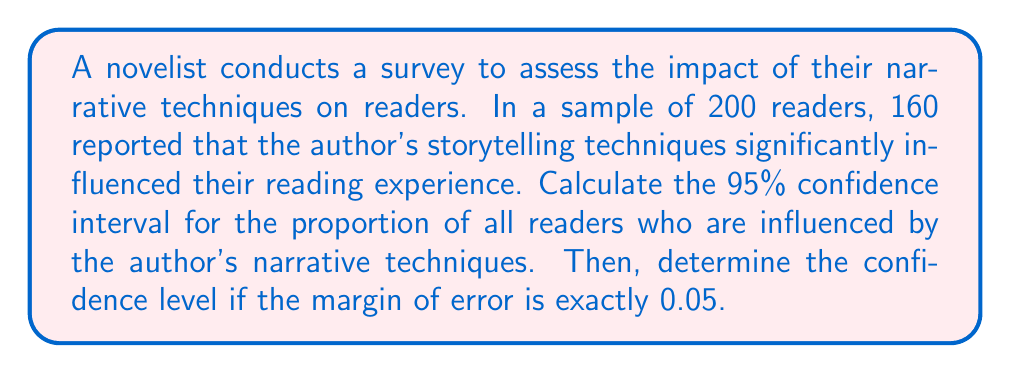Teach me how to tackle this problem. Let's approach this step-by-step:

1) First, calculate the sample proportion:
   $\hat{p} = \frac{160}{200} = 0.8$

2) For a 95% confidence interval, the z-score is 1.96.

3) Calculate the standard error:
   $SE = \sqrt{\frac{\hat{p}(1-\hat{p})}{n}} = \sqrt{\frac{0.8(1-0.8)}{200}} = 0.0283$

4) Calculate the margin of error for 95% confidence:
   $ME = z \cdot SE = 1.96 \cdot 0.0283 = 0.0554$

5) The 95% confidence interval is:
   $(\hat{p} - ME, \hat{p} + ME) = (0.8 - 0.0554, 0.8 + 0.0554) = (0.7446, 0.8554)$

6) To find the confidence level for a margin of error of exactly 0.05:
   $0.05 = z \cdot SE$
   $z = \frac{0.05}{SE} = \frac{0.05}{0.0283} = 1.77$

7) Use a z-table to find the confidence level corresponding to z = 1.77:
   The area between -1.77 and 1.77 in a standard normal distribution is approximately 0.9234.

8) Convert to percentage: 0.9234 * 100 = 92.34%

Therefore, the confidence level for a margin of error of 0.05 is approximately 92.34%.
Answer: 92.34% 